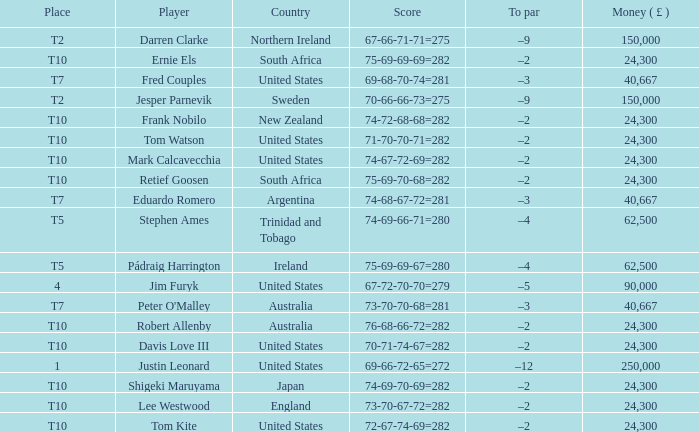Could you help me parse every detail presented in this table? {'header': ['Place', 'Player', 'Country', 'Score', 'To par', 'Money ( £ )'], 'rows': [['T2', 'Darren Clarke', 'Northern Ireland', '67-66-71-71=275', '–9', '150,000'], ['T10', 'Ernie Els', 'South Africa', '75-69-69-69=282', '–2', '24,300'], ['T7', 'Fred Couples', 'United States', '69-68-70-74=281', '–3', '40,667'], ['T2', 'Jesper Parnevik', 'Sweden', '70-66-66-73=275', '–9', '150,000'], ['T10', 'Frank Nobilo', 'New Zealand', '74-72-68-68=282', '–2', '24,300'], ['T10', 'Tom Watson', 'United States', '71-70-70-71=282', '–2', '24,300'], ['T10', 'Mark Calcavecchia', 'United States', '74-67-72-69=282', '–2', '24,300'], ['T10', 'Retief Goosen', 'South Africa', '75-69-70-68=282', '–2', '24,300'], ['T7', 'Eduardo Romero', 'Argentina', '74-68-67-72=281', '–3', '40,667'], ['T5', 'Stephen Ames', 'Trinidad and Tobago', '74-69-66-71=280', '–4', '62,500'], ['T5', 'Pádraig Harrington', 'Ireland', '75-69-69-67=280', '–4', '62,500'], ['4', 'Jim Furyk', 'United States', '67-72-70-70=279', '–5', '90,000'], ['T7', "Peter O'Malley", 'Australia', '73-70-70-68=281', '–3', '40,667'], ['T10', 'Robert Allenby', 'Australia', '76-68-66-72=282', '–2', '24,300'], ['T10', 'Davis Love III', 'United States', '70-71-74-67=282', '–2', '24,300'], ['1', 'Justin Leonard', 'United States', '69-66-72-65=272', '–12', '250,000'], ['T10', 'Shigeki Maruyama', 'Japan', '74-69-70-69=282', '–2', '24,300'], ['T10', 'Lee Westwood', 'England', '73-70-67-72=282', '–2', '24,300'], ['T10', 'Tom Kite', 'United States', '72-67-74-69=282', '–2', '24,300']]} What is the money won by Frank Nobilo? 1.0. 